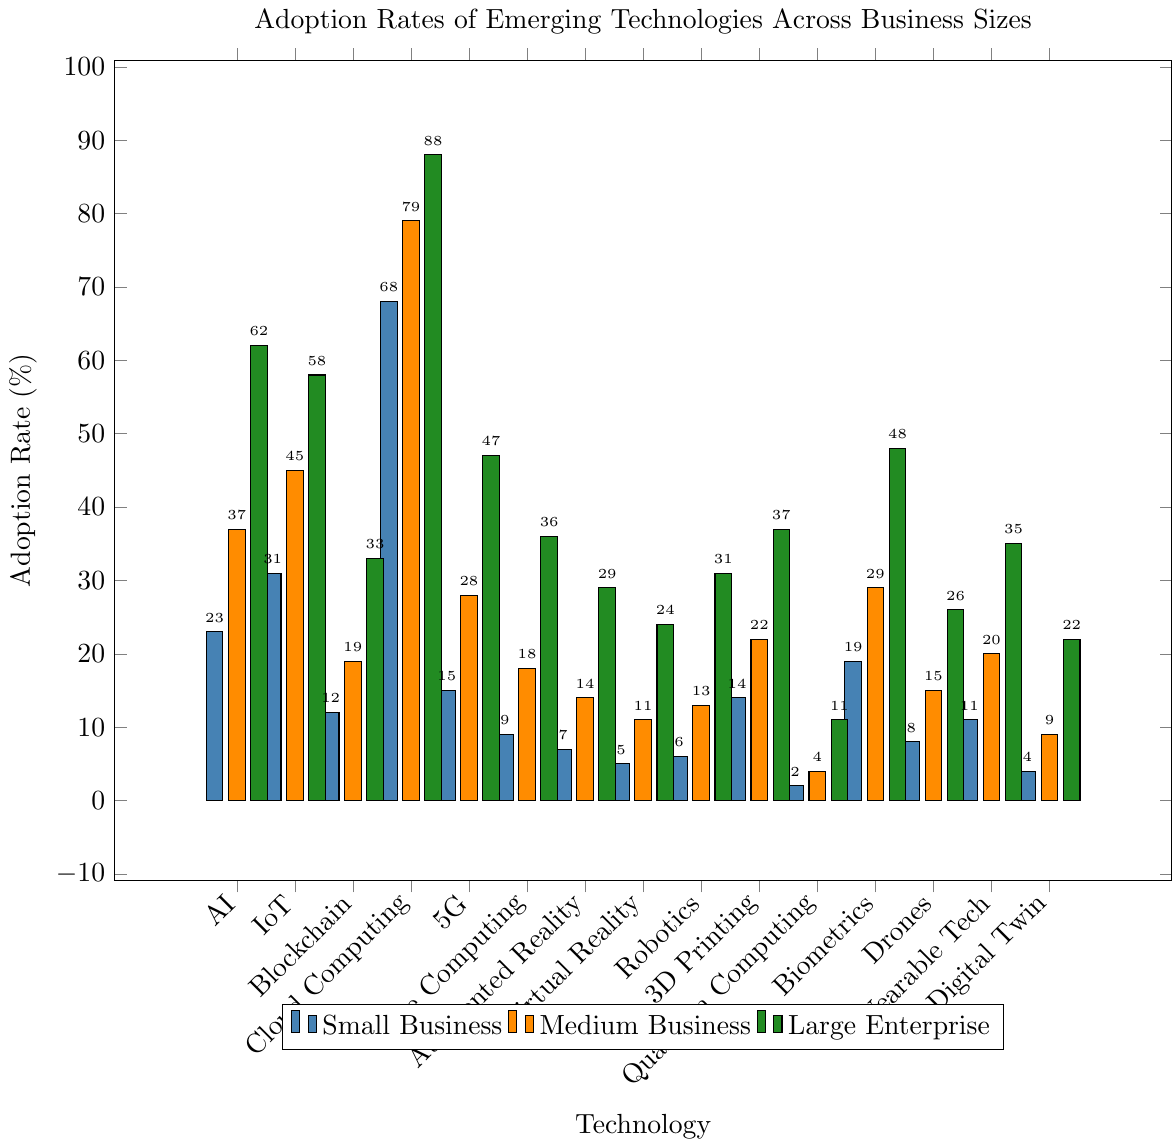What is the adoption rate of AI in large enterprises compared to small businesses? Look at the bar representing AI adoption in large enterprises (green) and in small businesses (blue); the values are 62% and 23%, respectively. The difference is calculated by subtracting 23 from 62. 62 - 23 = 39
Answer: 39% Which technology has the lowest adoption rate in small businesses? Check the heights of the blue bars for each technology and identify the one with the lowest height. Quantum Computing has the smallest adoption rate at 2%.
Answer: Quantum Computing Which business size shows the highest adoption rate for Cloud Computing? Compare the heights of the Cloud Computing bars across all three sizes; the green bar for large enterprises is the tallest at 88%.
Answer: Large enterprises What is the average adoption rate of Blockchain across all business sizes? Add the adoption rates of Blockchain: 12 (Small) + 19 (Medium) + 33 (Large) = 64. Divide by the number of groups (3). 64/3 ≈ 21.33
Answer: 21.33% How does the adoption rate of 5G in medium businesses compare to small businesses? Look at the bars representing 5G for both small (blue) and medium (orange) businesses; the values are 15% and 28%. The difference is calculated by subtracting 15 from 28. 28 - 15 = 13
Answer: 13% Which two technologies show the largest difference in adoption rates for large enterprises? Compare the green bars' heights for all technologies to find the two with the most significant difference. Cloud Computing (88%) and Quantum Computing (11%) have the largest difference. 88 - 11 = 77
Answer: 77% What's the total adoption rate of Wearable Tech across all business sizes? Sum the adoption rates of Wearable Tech: 11 (Small) + 20 (Medium) + 35 (Large) = 66.
Answer: 66% Which size of businesses has the highest overall adoption rate for AI, IoT, and Cloud Computing combined? First, sum the adoption rates for AI, IoT, and Cloud Computing for each business size: Small: 23+31+68=122, Medium: 37+45+79=161, Large: 62+58+88=208. The largest sum is for large enterprises.
Answer: Large enterprises What is the range of adoption rates for Drones across different business sizes? Identify the highest and lowest values for Drones adoption: 26 (Large), 8 (Small). The range is the difference between these two values. 26 - 8 = 18
Answer: 18% What percentage more do medium businesses adopt Biometrics compared to small businesses? Look at the values for Biometrics adoption: 29% for Medium and 19% for Small. The difference is calculated, and then divided by the small business rate multiplied by 100. ((29 - 19)/19) * 100 ≈ 52.63%
Answer: 52.63% 